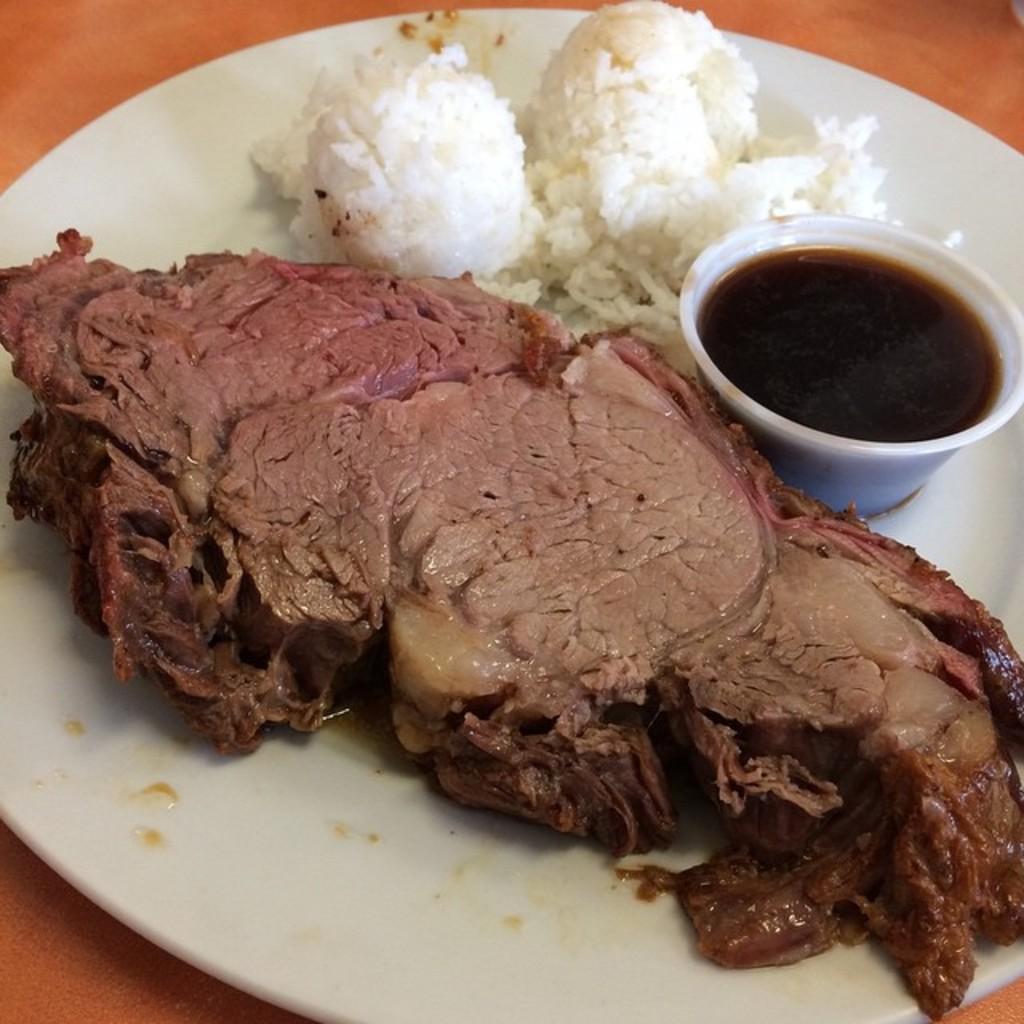Please provide a concise description of this image. In this image I can see a food which is in white,brown color. I can see a bowl and something is in it. The plate is on orange color surface. 